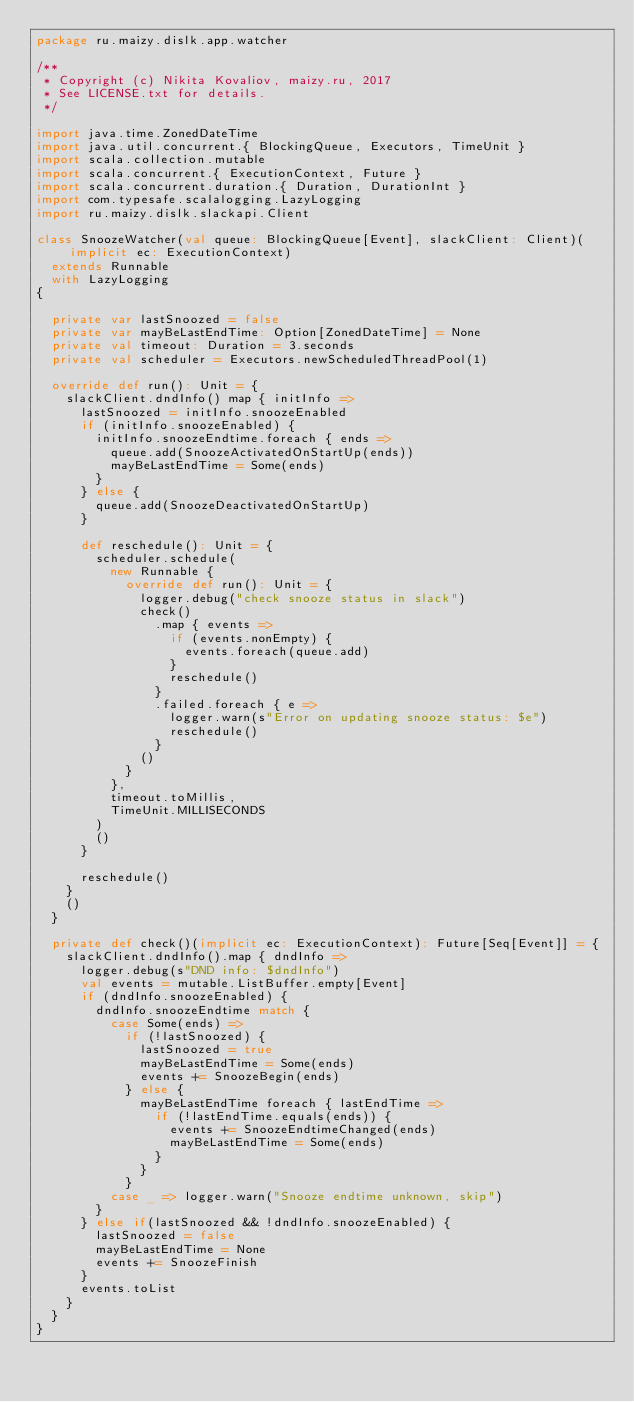Convert code to text. <code><loc_0><loc_0><loc_500><loc_500><_Scala_>package ru.maizy.dislk.app.watcher

/**
 * Copyright (c) Nikita Kovaliov, maizy.ru, 2017
 * See LICENSE.txt for details.
 */

import java.time.ZonedDateTime
import java.util.concurrent.{ BlockingQueue, Executors, TimeUnit }
import scala.collection.mutable
import scala.concurrent.{ ExecutionContext, Future }
import scala.concurrent.duration.{ Duration, DurationInt }
import com.typesafe.scalalogging.LazyLogging
import ru.maizy.dislk.slackapi.Client

class SnoozeWatcher(val queue: BlockingQueue[Event], slackClient: Client)(implicit ec: ExecutionContext)
  extends Runnable
  with LazyLogging
{

  private var lastSnoozed = false
  private var mayBeLastEndTime: Option[ZonedDateTime] = None
  private val timeout: Duration = 3.seconds
  private val scheduler = Executors.newScheduledThreadPool(1)

  override def run(): Unit = {
    slackClient.dndInfo() map { initInfo =>
      lastSnoozed = initInfo.snoozeEnabled
      if (initInfo.snoozeEnabled) {
        initInfo.snoozeEndtime.foreach { ends =>
          queue.add(SnoozeActivatedOnStartUp(ends))
          mayBeLastEndTime = Some(ends)
        }
      } else {
        queue.add(SnoozeDeactivatedOnStartUp)
      }

      def reschedule(): Unit = {
        scheduler.schedule(
          new Runnable {
            override def run(): Unit = {
              logger.debug("check snooze status in slack")
              check()
                .map { events =>
                  if (events.nonEmpty) {
                    events.foreach(queue.add)
                  }
                  reschedule()
                }
                .failed.foreach { e =>
                  logger.warn(s"Error on updating snooze status: $e")
                  reschedule()
                }
              ()
            }
          },
          timeout.toMillis,
          TimeUnit.MILLISECONDS
        )
        ()
      }

      reschedule()
    }
    ()
  }

  private def check()(implicit ec: ExecutionContext): Future[Seq[Event]] = {
    slackClient.dndInfo().map { dndInfo =>
      logger.debug(s"DND info: $dndInfo")
      val events = mutable.ListBuffer.empty[Event]
      if (dndInfo.snoozeEnabled) {
        dndInfo.snoozeEndtime match {
          case Some(ends) =>
            if (!lastSnoozed) {
              lastSnoozed = true
              mayBeLastEndTime = Some(ends)
              events += SnoozeBegin(ends)
            } else {
              mayBeLastEndTime foreach { lastEndTime =>
                if (!lastEndTime.equals(ends)) {
                  events += SnoozeEndtimeChanged(ends)
                  mayBeLastEndTime = Some(ends)
                }
              }
            }
          case _ => logger.warn("Snooze endtime unknown, skip")
        }
      } else if(lastSnoozed && !dndInfo.snoozeEnabled) {
        lastSnoozed = false
        mayBeLastEndTime = None
        events += SnoozeFinish
      }
      events.toList
    }
  }
}
</code> 